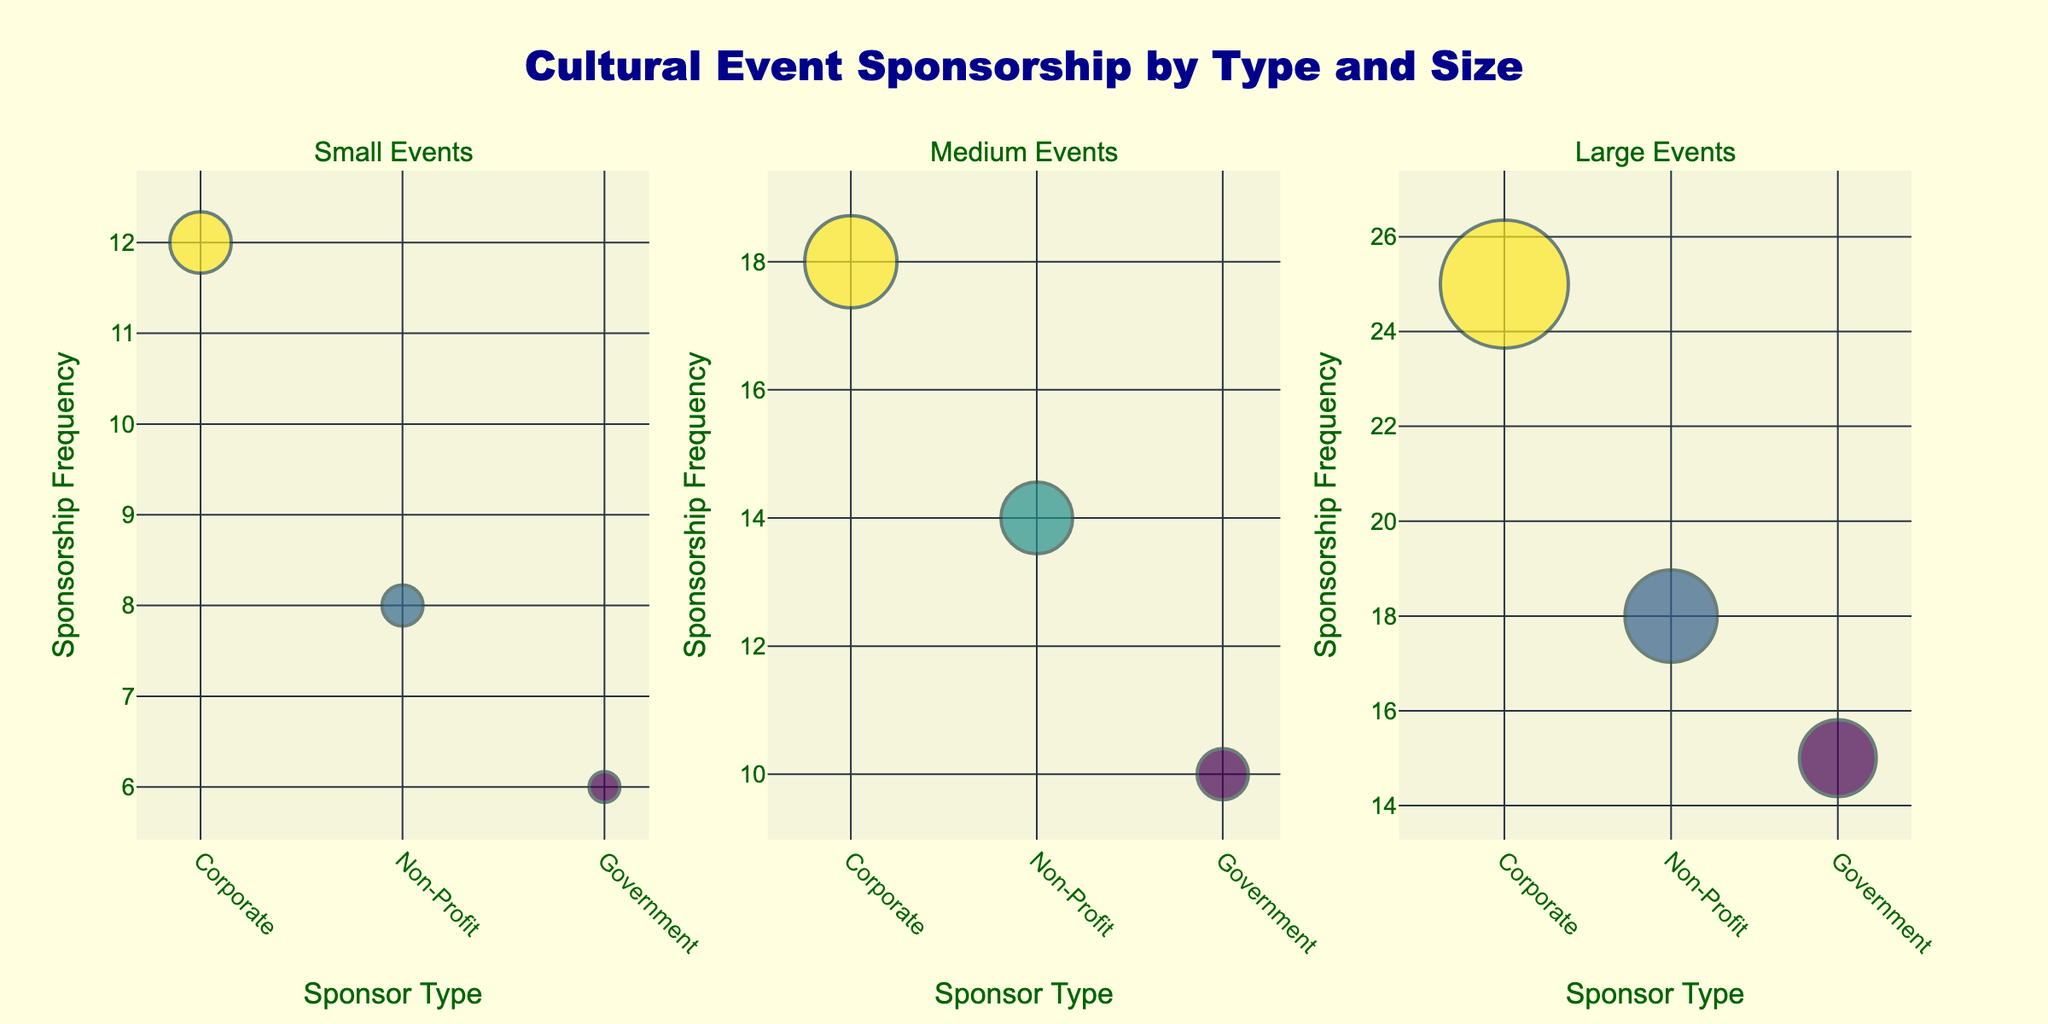How many sponsor types are shown in the subplot for small events? There are three sponsor types shown in the subplot for small events: Corporate, Non-Profit, and Government, based on the different categories along the x-axis.
Answer: 3 Which sponsor has the highest sponsorship frequency in large events? By looking at the subplot for large events, the largest bubble (indicating the highest sponsorship frequency) belongs to a Corporate sponsor, specifically Google.
Answer: Google What is the average sponsorship frequency for medium-sized events? To find the average sponsorship frequency for medium-sized events, sum the frequencies: Apple Inc. (18), Red Cross (14), and Smithsonian Institution (10), which equals 42. Divide this by the number of sponsor types (3): 42 / 3 = 14.
Answer: 14 Which event size has the highest number of sponsorship frequencies combined, and what is this total? The total sponsorship frequencies for each event size are: Small (12 + 8 + 6 = 26), Medium (18 + 14 + 10 = 42), and Large (25 + 18 + 15 = 58). The highest total is for Large events, equaling 58.
Answer: Large, 58 Does the Non-Profit sponsor type always have fewer sponsorship frequencies than the Corporate sponsor type? For Small events, Non-Profit (8) versus Corporate (12); for Medium events, Non-Profit (14) versus Corporate (18); for Large events, Non-Profit (18) versus Corporate (25). In each case, Non-Profit has fewer frequencies than Corporate.
Answer: Yes What is the sponsorship frequency difference between the largest and smallest event size for the Government sponsor type? The Government sponsorship frequency for Small events is 6, for Medium events is 10, and for Large events is 15. Therefore, the difference between Large and Small is 15 - 6 = 9.
Answer: 9 Which sponsor type has the most consistent frequencies across different event sizes? The Government sponsor type shows frequencies of 6 (Small), 10 (Medium), and 15 (Large), which have the least variation compared to the other sponsor types.
Answer: Government 